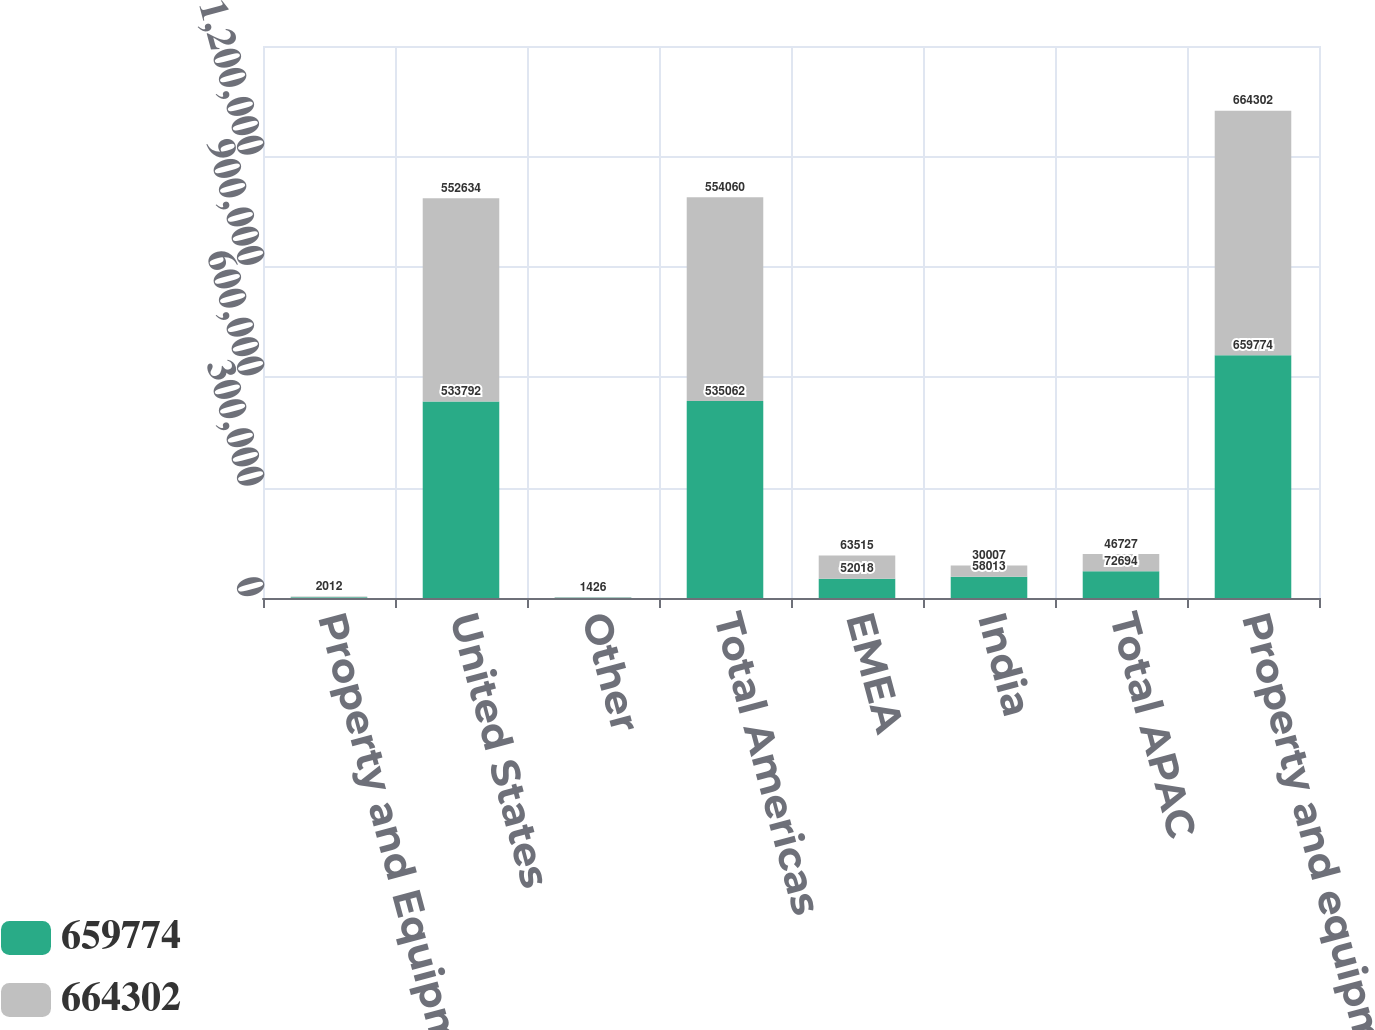Convert chart to OTSL. <chart><loc_0><loc_0><loc_500><loc_500><stacked_bar_chart><ecel><fcel>Property and Equipment<fcel>United States<fcel>Other<fcel>Total Americas<fcel>EMEA<fcel>India<fcel>Total APAC<fcel>Property and equipment net<nl><fcel>659774<fcel>2013<fcel>533792<fcel>1270<fcel>535062<fcel>52018<fcel>58013<fcel>72694<fcel>659774<nl><fcel>664302<fcel>2012<fcel>552634<fcel>1426<fcel>554060<fcel>63515<fcel>30007<fcel>46727<fcel>664302<nl></chart> 